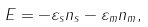Convert formula to latex. <formula><loc_0><loc_0><loc_500><loc_500>E = - \varepsilon _ { s } n _ { s } - \varepsilon _ { m } n _ { m } ,</formula> 